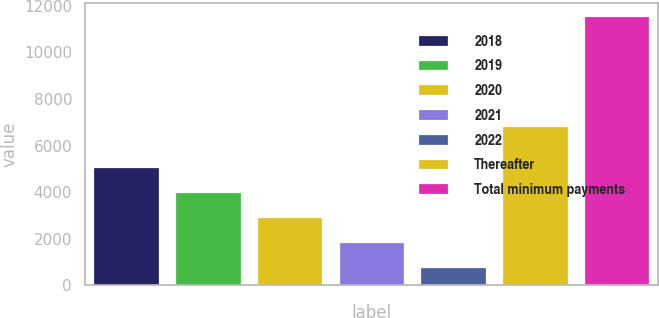Convert chart to OTSL. <chart><loc_0><loc_0><loc_500><loc_500><bar_chart><fcel>2018<fcel>2019<fcel>2020<fcel>2021<fcel>2022<fcel>Thereafter<fcel>Total minimum payments<nl><fcel>5092.26<fcel>4013.87<fcel>2935.48<fcel>1857.09<fcel>778.7<fcel>6829.1<fcel>11562.6<nl></chart> 